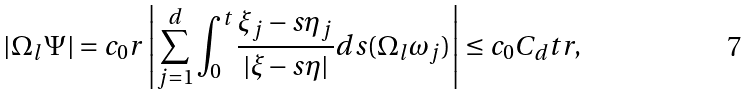<formula> <loc_0><loc_0><loc_500><loc_500>| \Omega _ { l } \Psi | = c _ { 0 } r \left | \sum _ { j = 1 } ^ { d } \int _ { 0 } ^ { t } \frac { \xi _ { j } - s \eta _ { j } } { | \xi - s \eta | } d s ( \Omega _ { l } \omega _ { j } ) \right | \leq c _ { 0 } C _ { d } t r ,</formula> 